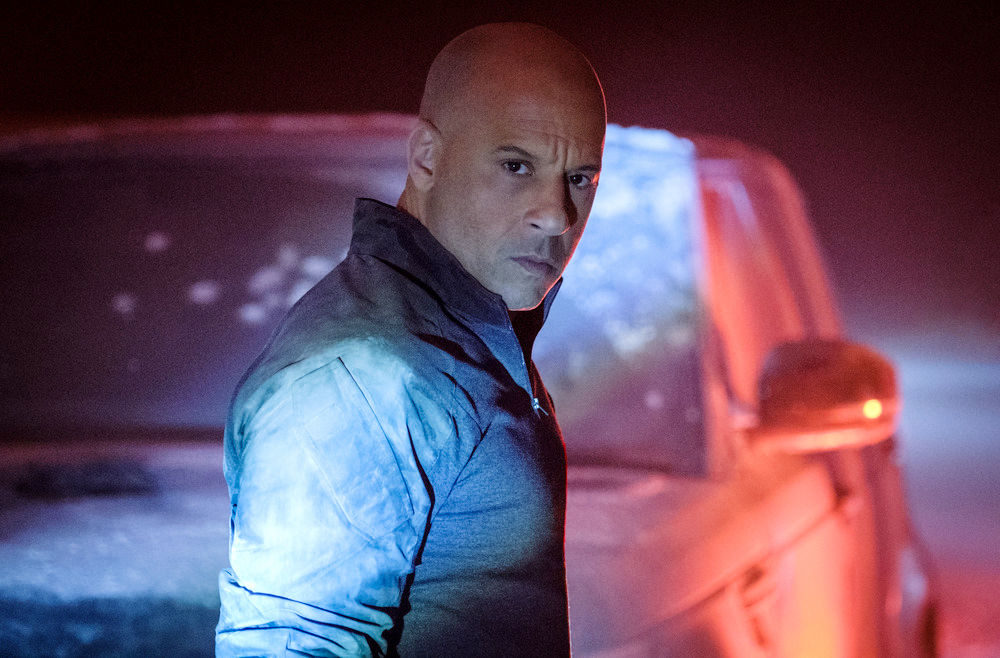What do you think the man in the image is thinking about? The man's intense gaze and serious expression suggest he might be contemplating a crucial decision or reflecting on recent events. His focus and the setting around him imply a moment of inner turmoil or resolution, potentially tied to an important mission or personal challenge. 